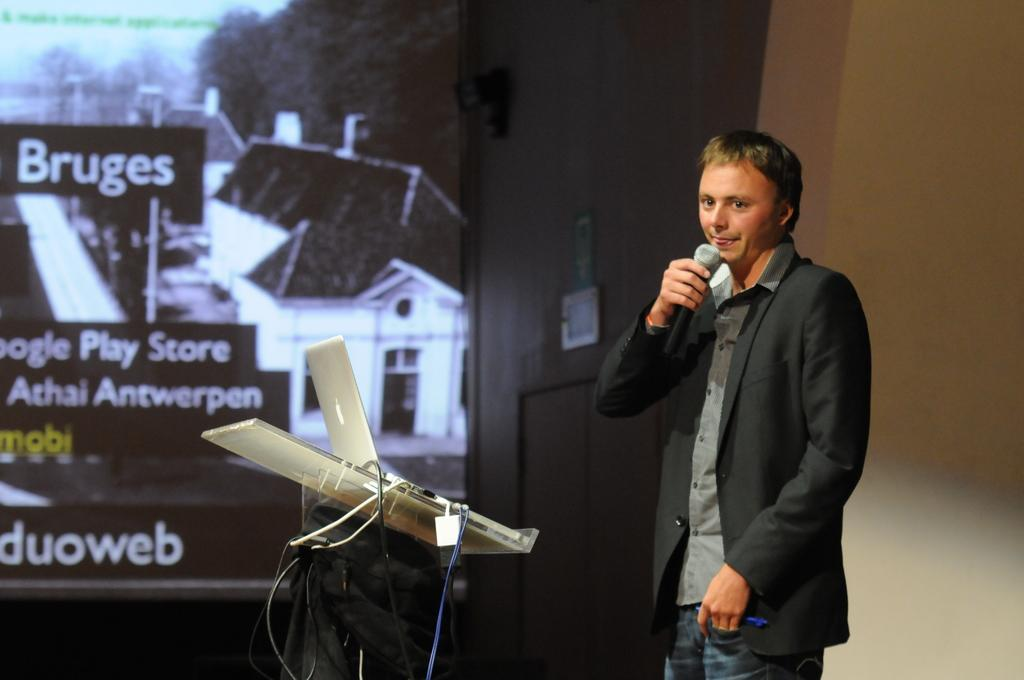What is the man in the image holding? The man is holding a mic. What object is on a stand in the image? There is a laptop on a stand in the image. What can be seen in the background of the image? There is a wall in the background of the image. How many dimes can be seen on the wall in the image? There are no dimes visible on the wall in the image. What type of connection is the man making with the audience in the image? The image does not provide information about the man's connection with the audience, as it only shows him holding a mic and standing near a laptop on a stand. 